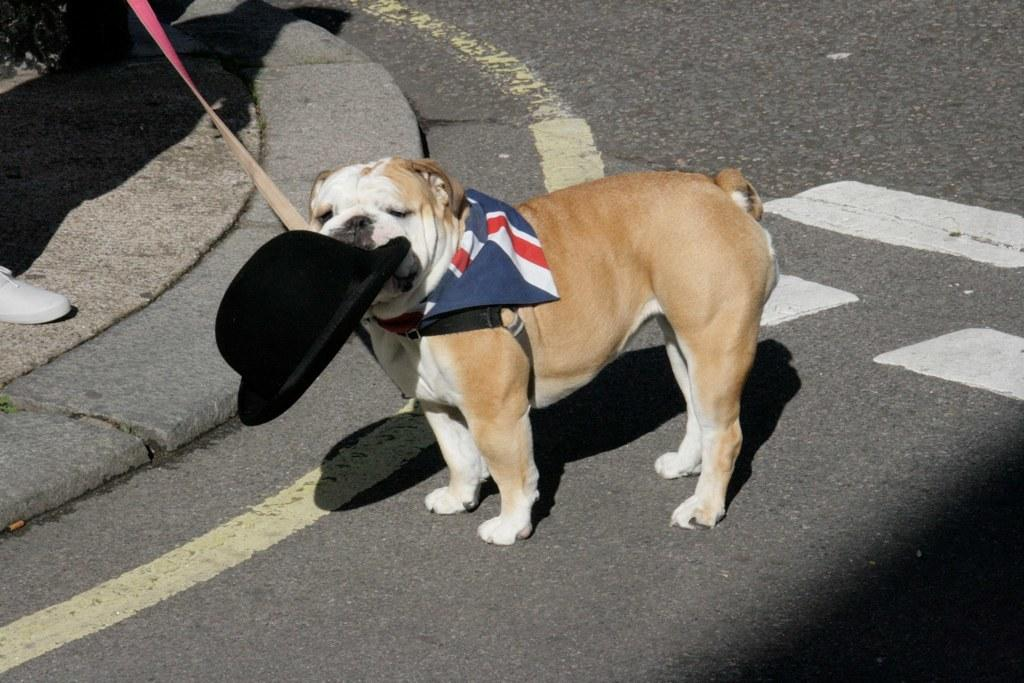What animal is present in the image? There is a dog in the image. Where is the dog located in the image? The dog is standing on the road. What is the dog holding in its mouth? The dog has a hat in its mouth. What objects can be seen on the left side of the image? There is a shoe and a dog's belt on the left side of the image. What type of party is happening in the image? There is no party present in the image; it features a dog standing on the road with a hat in its mouth. Is the dog causing any trouble in the image? There is no indication of trouble in the image. 